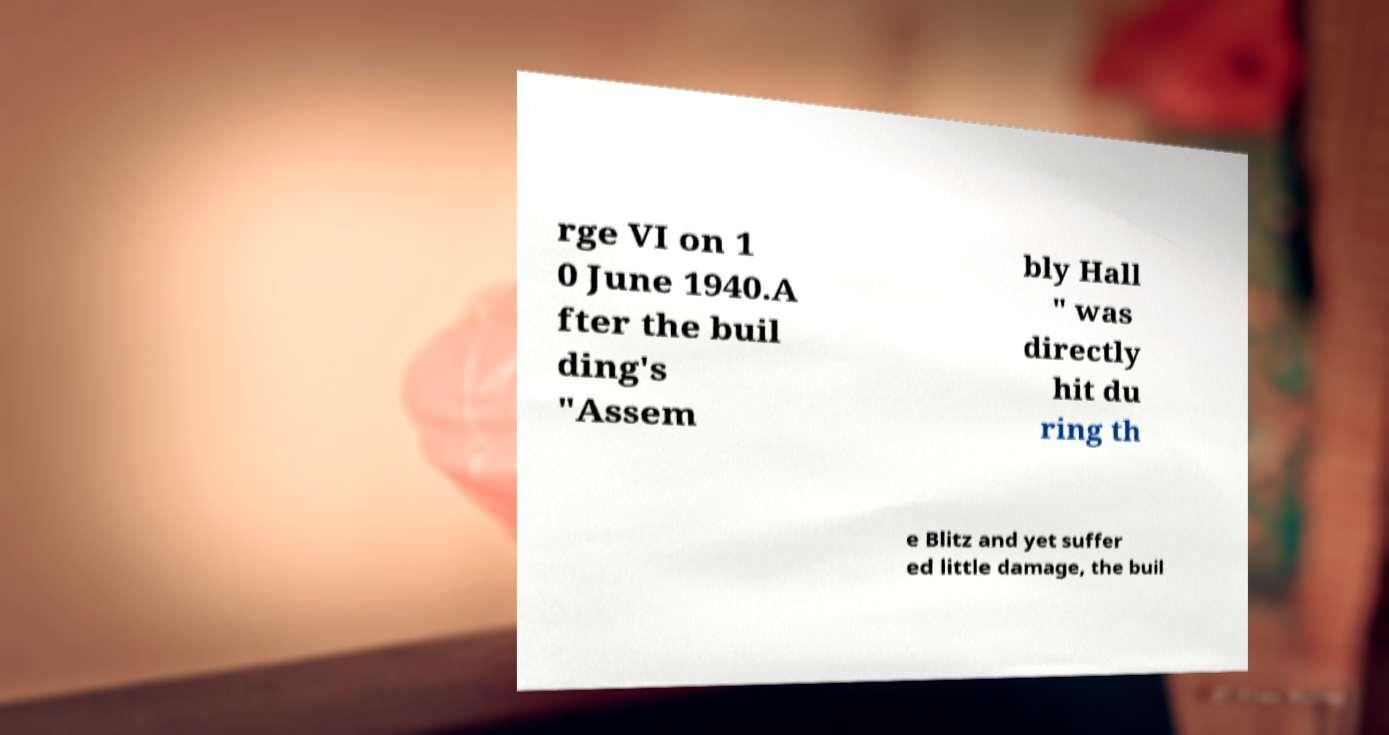Can you read and provide the text displayed in the image?This photo seems to have some interesting text. Can you extract and type it out for me? rge VI on 1 0 June 1940.A fter the buil ding's "Assem bly Hall " was directly hit du ring th e Blitz and yet suffer ed little damage, the buil 